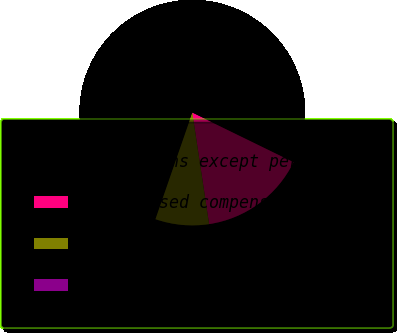Convert chart. <chart><loc_0><loc_0><loc_500><loc_500><pie_chart><fcel>In millions except per share<fcel>Share-based compensation<fcel>After tax<fcel>Net income per common share-<nl><fcel>76.92%<fcel>15.39%<fcel>7.69%<fcel>0.0%<nl></chart> 